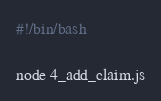<code> <loc_0><loc_0><loc_500><loc_500><_Bash_>#!/bin/bash

node 4_add_claim.js
</code> 